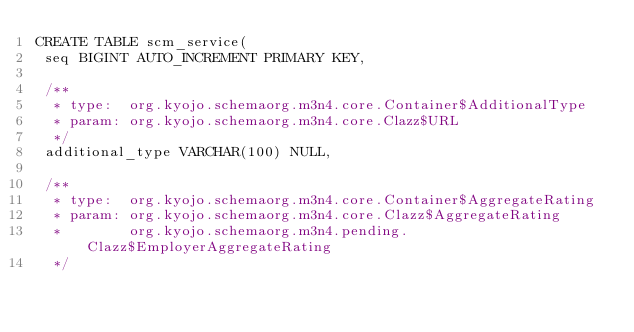<code> <loc_0><loc_0><loc_500><loc_500><_SQL_>CREATE TABLE scm_service(
 seq BIGINT AUTO_INCREMENT PRIMARY KEY,

 /**
  * type:  org.kyojo.schemaorg.m3n4.core.Container$AdditionalType
  * param: org.kyojo.schemaorg.m3n4.core.Clazz$URL
  */
 additional_type VARCHAR(100) NULL,

 /**
  * type:  org.kyojo.schemaorg.m3n4.core.Container$AggregateRating
  * param: org.kyojo.schemaorg.m3n4.core.Clazz$AggregateRating
  *        org.kyojo.schemaorg.m3n4.pending.Clazz$EmployerAggregateRating
  */</code> 